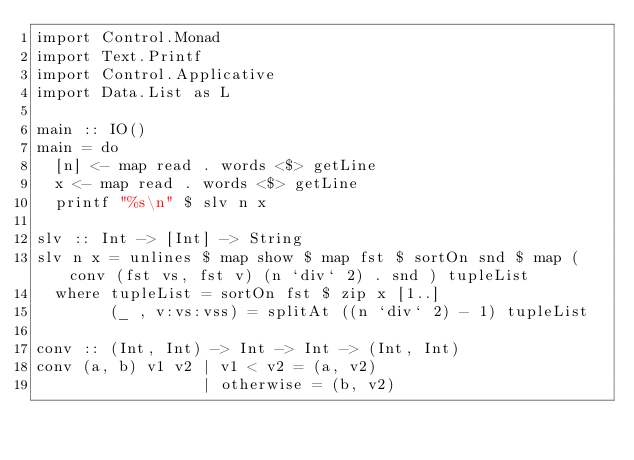Convert code to text. <code><loc_0><loc_0><loc_500><loc_500><_Haskell_>import Control.Monad
import Text.Printf
import Control.Applicative
import Data.List as L

main :: IO()
main = do
  [n] <- map read . words <$> getLine
  x <- map read . words <$> getLine
  printf "%s\n" $ slv n x

slv :: Int -> [Int] -> String
slv n x = unlines $ map show $ map fst $ sortOn snd $ map (conv (fst vs, fst v) (n `div` 2) . snd ) tupleList
  where tupleList = sortOn fst $ zip x [1..]
        (_ , v:vs:vss) = splitAt ((n `div` 2) - 1) tupleList

conv :: (Int, Int) -> Int -> Int -> (Int, Int)
conv (a, b) v1 v2 | v1 < v2 = (a, v2)
                  | otherwise = (b, v2)</code> 